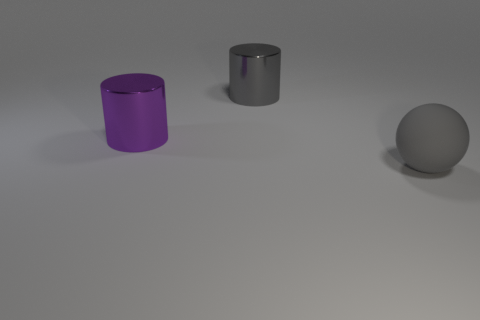Can you describe the lighting in the image? The lighting in the image is soft and diffused, coming from above and creating gentle shadows beneath the objects. This suggests an indoor setting with either natural light from a window or artificial light, possibly from a bulb that's not directly visible in the image. 